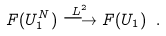Convert formula to latex. <formula><loc_0><loc_0><loc_500><loc_500>F ( U _ { 1 } ^ { N } ) \stackrel { L ^ { 2 } } { \longrightarrow } F ( U _ { 1 } ) \ .</formula> 